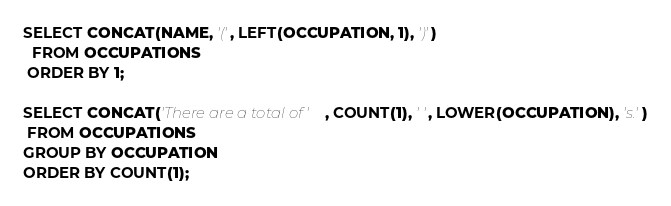<code> <loc_0><loc_0><loc_500><loc_500><_SQL_>SELECT CONCAT(NAME, '(', LEFT(OCCUPATION, 1), ')')
  FROM OCCUPATIONS
 ORDER BY 1;
 
SELECT CONCAT('There are a total of ', COUNT(1), ' ', LOWER(OCCUPATION), 's.')
 FROM OCCUPATIONS
GROUP BY OCCUPATION
ORDER BY COUNT(1);</code> 